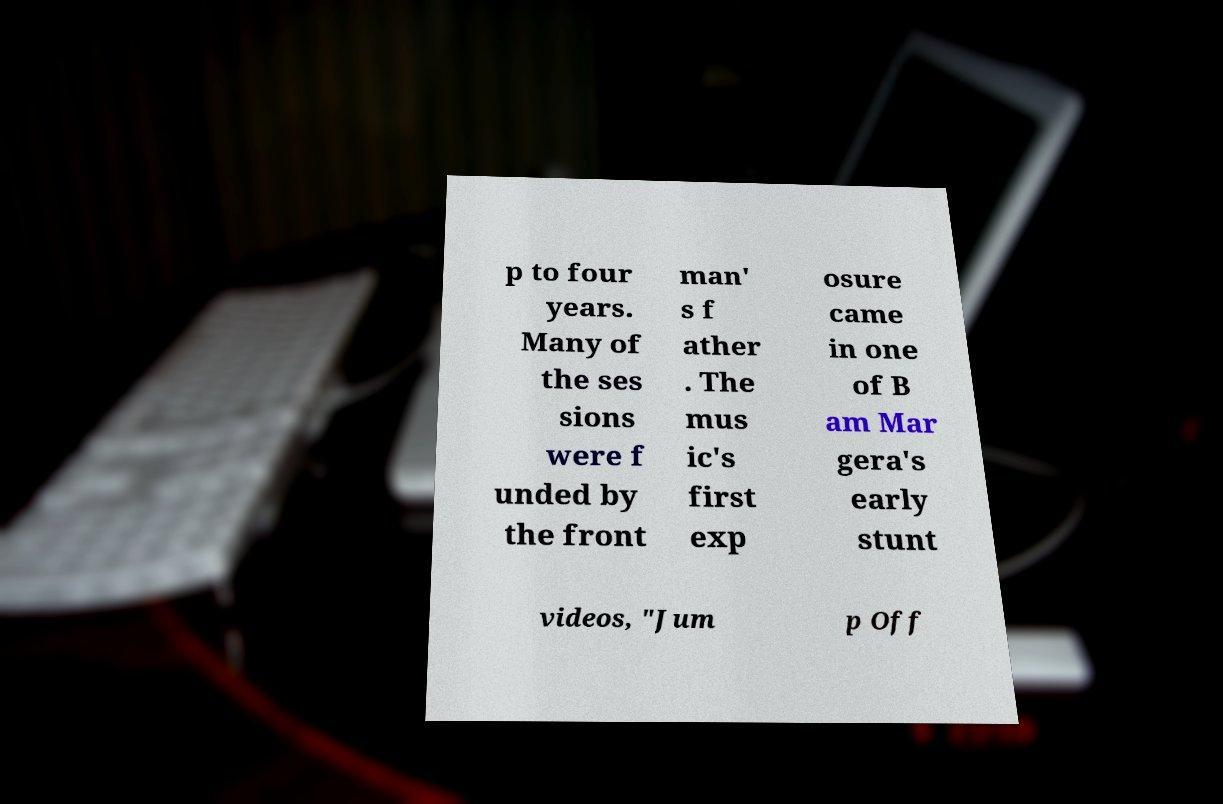What messages or text are displayed in this image? I need them in a readable, typed format. p to four years. Many of the ses sions were f unded by the front man' s f ather . The mus ic's first exp osure came in one of B am Mar gera's early stunt videos, "Jum p Off 